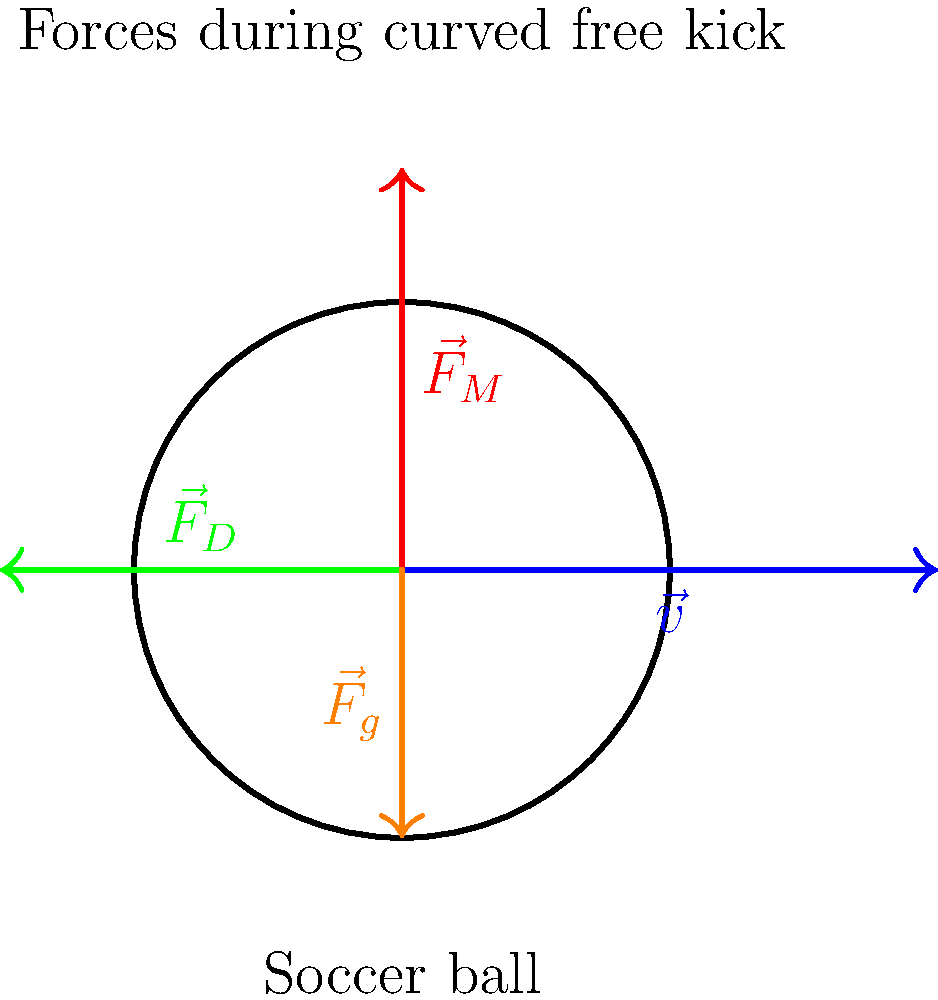During a curved free kick in soccer, which force is primarily responsible for the ball's lateral deviation from its initial trajectory, and how is it generated? To understand the forces acting on a soccer ball during a curved free kick, let's break it down step-by-step:

1. The main forces acting on the ball are:
   a) Gravity ($\vec{F}_g$)
   b) Air resistance (drag force, $\vec{F}_D$)
   c) Magnus force ($\vec{F}_M$)

2. Gravity always acts downward and is constant throughout the ball's flight.

3. Air resistance opposes the ball's motion and is proportional to the square of the ball's velocity.

4. The Magnus force is the key to the ball's curved trajectory:
   a) It's created by the ball's spin, which is imparted by the kicker.
   b) The spin causes a pressure difference on opposite sides of the ball due to the relative air speeds.
   c) This pressure difference results in a force perpendicular to both the velocity and spin axis.

5. For a right-footed kicker striking the ball on the right side:
   a) The ball spins counterclockwise when viewed from above.
   b) This creates a Magnus force pointing to the left of the ball's trajectory.

6. The combination of these forces results in the ball's curved path:
   a) Initial velocity provides forward motion.
   b) Magnus force causes lateral deviation.
   c) Gravity pulls the ball downward.
   d) Air resistance gradually slows the ball.

7. The magnitude of the curve depends on:
   a) The initial spin rate of the ball.
   b) The ball's velocity.
   c) The ball's surface properties.
   d) Air density and other environmental factors.

In conclusion, the Magnus force is primarily responsible for the lateral deviation of the ball during a curved free kick, generated by the ball's spin interacting with the air flow around it.
Answer: Magnus force, generated by ball spin 